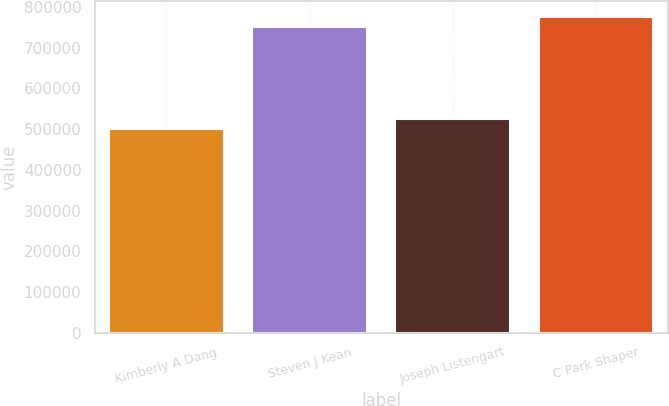<chart> <loc_0><loc_0><loc_500><loc_500><bar_chart><fcel>Kimberly A Dang<fcel>Steven J Kean<fcel>Joseph Listengart<fcel>C Park Shaper<nl><fcel>500000<fcel>750000<fcel>525000<fcel>775000<nl></chart> 